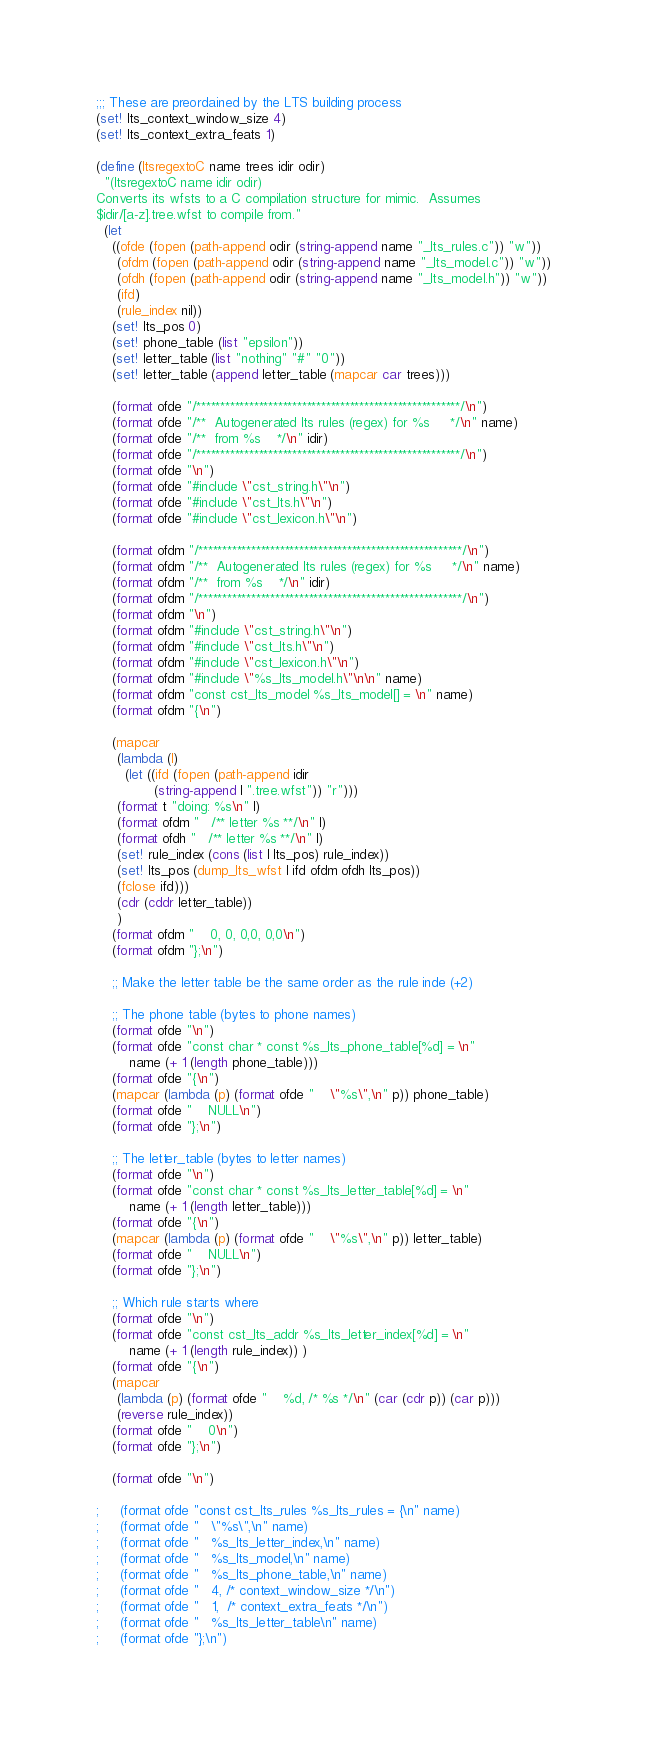<code> <loc_0><loc_0><loc_500><loc_500><_Scheme_>
;;; These are preordained by the LTS building process
(set! lts_context_window_size 4)
(set! lts_context_extra_feats 1)

(define (ltsregextoC name trees idir odir)
  "(ltsregextoC name idir odir)
Converts its wfsts to a C compilation structure for mimic.  Assumes
$idir/[a-z].tree.wfst to compile from."
  (let 
    ((ofde (fopen (path-append odir (string-append name "_lts_rules.c")) "w"))
     (ofdm (fopen (path-append odir (string-append name "_lts_model.c")) "w"))
     (ofdh (fopen (path-append odir (string-append name "_lts_model.h")) "w"))
     (ifd)
     (rule_index nil))
    (set! lts_pos 0)
    (set! phone_table (list "epsilon"))
    (set! letter_table (list "nothing" "#" "0"))
    (set! letter_table (append letter_table (mapcar car trees)))

    (format ofde "/*******************************************************/\n")
    (format ofde "/**  Autogenerated lts rules (regex) for %s     */\n" name)
    (format ofde "/**  from %s    */\n" idir)
    (format ofde "/*******************************************************/\n")
    (format ofde "\n")
    (format ofde "#include \"cst_string.h\"\n")
    (format ofde "#include \"cst_lts.h\"\n")
    (format ofde "#include \"cst_lexicon.h\"\n")

    (format ofdm "/*******************************************************/\n")
    (format ofdm "/**  Autogenerated lts rules (regex) for %s     */\n" name)
    (format ofdm "/**  from %s    */\n" idir)
    (format ofdm "/*******************************************************/\n")
    (format ofdm "\n")
    (format ofdm "#include \"cst_string.h\"\n")
    (format ofdm "#include \"cst_lts.h\"\n")
    (format ofdm "#include \"cst_lexicon.h\"\n")
    (format ofdm "#include \"%s_lts_model.h\"\n\n" name)
    (format ofdm "const cst_lts_model %s_lts_model[] = \n" name)
    (format ofdm "{\n")

    (mapcar
     (lambda (l)
       (let ((ifd (fopen (path-append idir 
			  (string-append l ".tree.wfst")) "r")))
	 (format t "doing: %s\n" l)
	 (format ofdm "   /** letter %s **/\n" l)
	 (format ofdh "   /** letter %s **/\n" l)
	 (set! rule_index (cons (list l lts_pos) rule_index))
	 (set! lts_pos (dump_lts_wfst l ifd ofdm ofdh lts_pos))
	 (fclose ifd)))
     (cdr (cddr letter_table))
     )
    (format ofdm "    0, 0, 0,0, 0,0\n")
    (format ofdm "};\n")

    ;; Make the letter table be the same order as the rule inde (+2)

    ;; The phone table (bytes to phone names)
    (format ofde "\n")
    (format ofde "const char * const %s_lts_phone_table[%d] = \n" 
	    name (+ 1 (length phone_table)))
    (format ofde "{\n")
    (mapcar (lambda (p) (format ofde "    \"%s\",\n" p)) phone_table)
    (format ofde "    NULL\n")
    (format ofde "};\n")

    ;; The letter_table (bytes to letter names)
    (format ofde "\n")
    (format ofde "const char * const %s_lts_letter_table[%d] = \n" 
	    name (+ 1 (length letter_table)))
    (format ofde "{\n")
    (mapcar (lambda (p) (format ofde "    \"%s\",\n" p)) letter_table)
    (format ofde "    NULL\n")
    (format ofde "};\n")

    ;; Which rule starts where
    (format ofde "\n")
    (format ofde "const cst_lts_addr %s_lts_letter_index[%d] = \n" 
	    name (+ 1 (length rule_index)) )
    (format ofde "{\n")
    (mapcar 
     (lambda (p) (format ofde "    %d, /* %s */\n" (car (cdr p)) (car p)))
     (reverse rule_index))
    (format ofde "    0\n")
    (format ofde "};\n")

    (format ofde "\n")

;     (format ofde "const cst_lts_rules %s_lts_rules = {\n" name)
;     (format ofde "   \"%s\",\n" name)
;     (format ofde "   %s_lts_letter_index,\n" name)
;     (format ofde "   %s_lts_model,\n" name)
;     (format ofde "   %s_lts_phone_table,\n" name)
;     (format ofde "   4, /* context_window_size */\n")
;     (format ofde "   1,  /* context_extra_feats */\n")
;     (format ofde "   %s_lts_letter_table\n" name)
;     (format ofde "};\n")</code> 